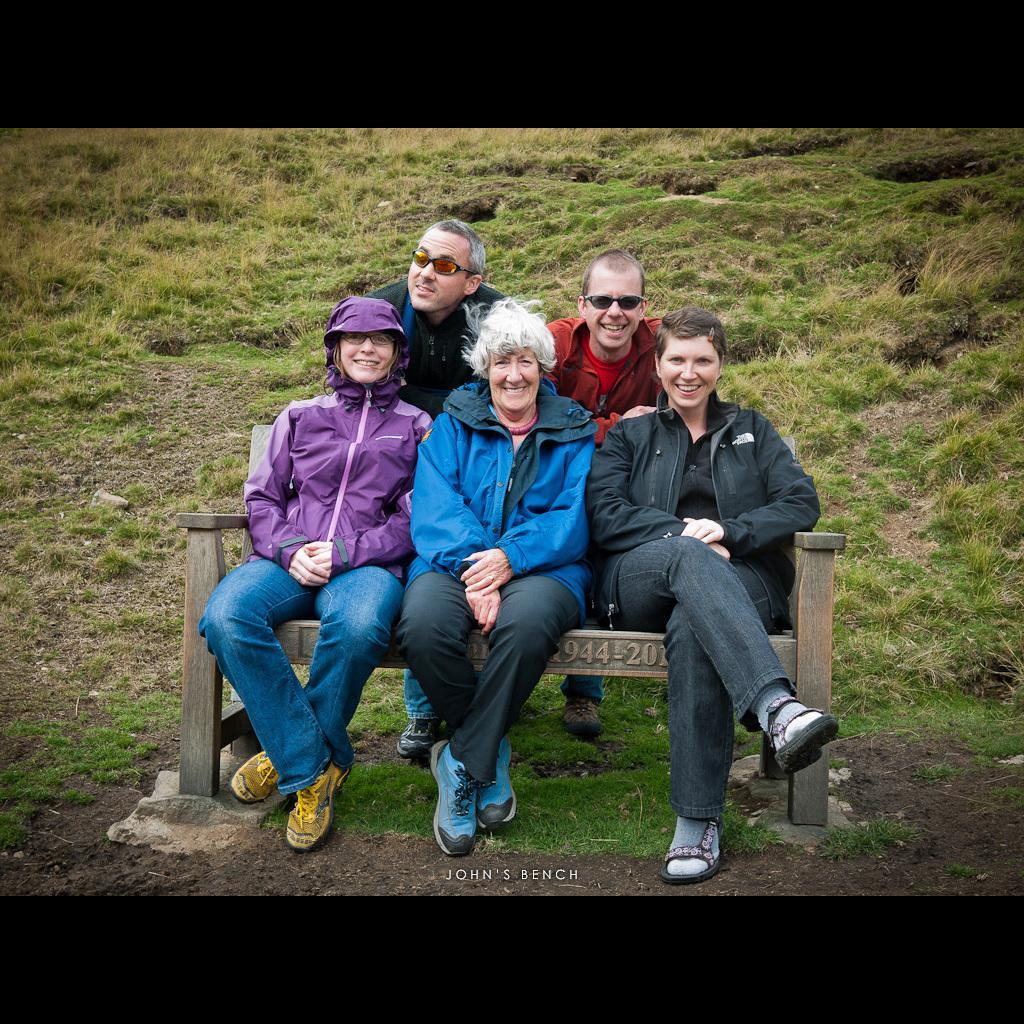Describe this image in one or two sentences. In this image I can see five persons and I can see three of them are sitting on a bench. I can see all of them are wearing jacket and two of them are wearing shade. I can also see grass and here on this bench I can see something is written. 